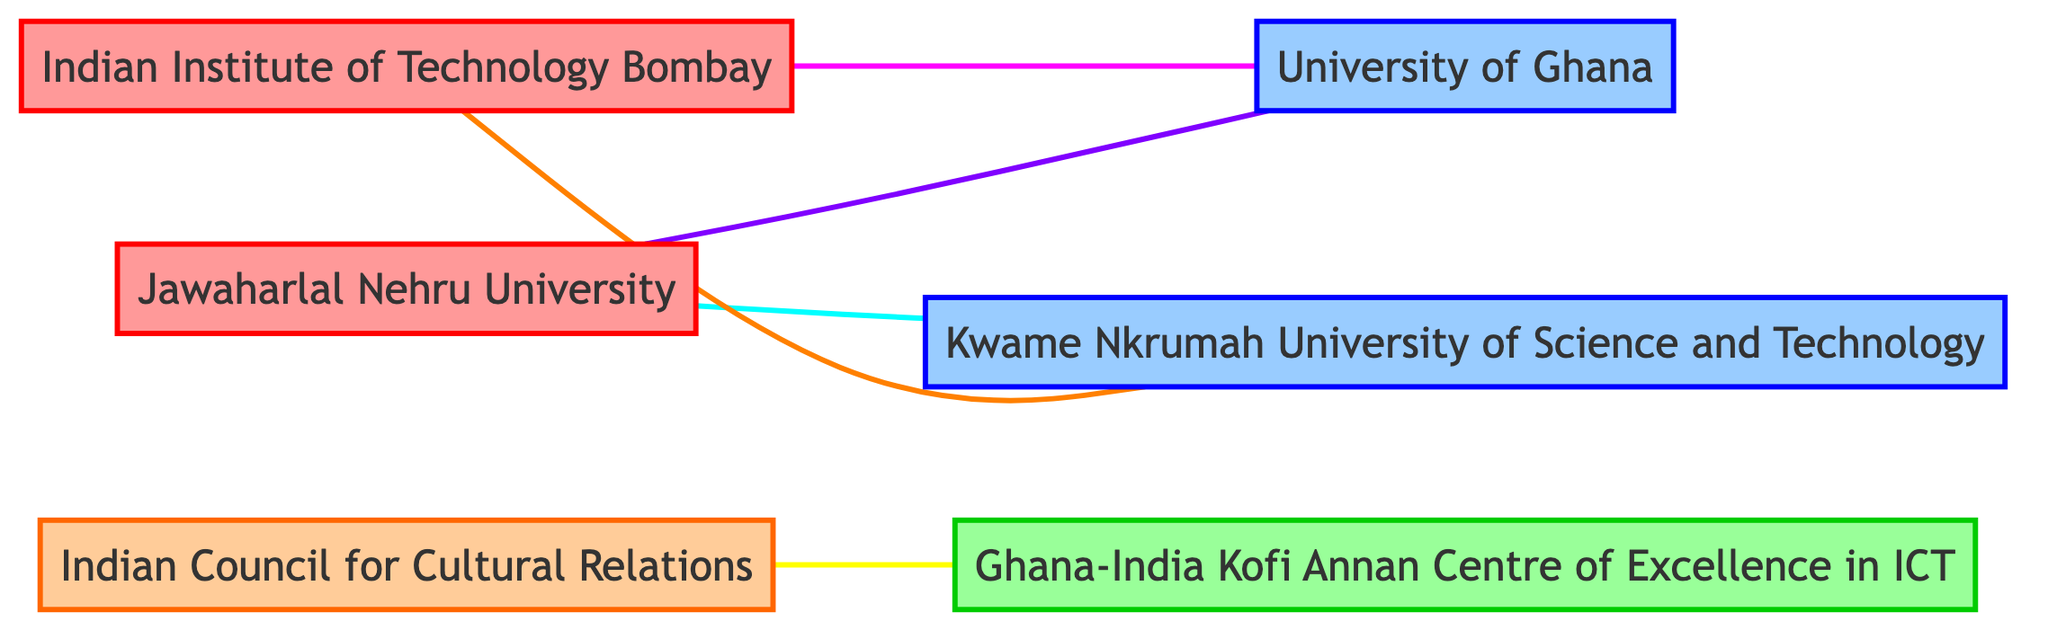What are the types of Indian educational institutions in the diagram? The diagram includes two nodes representing Indian educational institutions: Indian Institute of Technology Bombay and Jawaharlal Nehru University. Both are labeled as "Indian Educational Institution."
Answer: Indian Institute of Technology Bombay, Jawaharlal Nehru University How many edges represent collaboration between Indian and Ghanaian institutions? There are four edges connecting Indian institutions to Ghanaian institutions: one between Indian Institute of Technology Bombay and University of Ghana, another between Jawaharlal Nehru University and Kwame Nkrumah University of Science and Technology, and two more between Indian Institute of Technology Bombay and Kwame Nkrumah University of Science and Technology, and Jawaharlal Nehru University and University of Ghana. This totals four edges.
Answer: 4 What type of relationship exists between Indian Institute of Technology Bombay and University of Ghana? The edge connecting Indian Institute of Technology Bombay and University of Ghana is labeled as "Joint Research Projects," indicative of their collaboration.
Answer: Joint Research Projects Which Ghanaian organization collaborates with the Indian Council for Cultural Relations? The Ghanaian organization that collaborates with the Indian Council for Cultural Relations is the Ghana-India Kofi Annan Centre of Excellence in ICT, as indicated by the edge connecting the two nodes.
Answer: Ghana-India Kofi Annan Centre of Excellence in ICT How many nodes represent Ghanaian educational institutions? The diagram presents two nodes designated as Ghanaian educational institutions: University of Ghana and Kwame Nkrumah University of Science and Technology. Therefore, the count of Ghanaian educational institutions represented is two.
Answer: 2 What is the relationship type between Jawaharlal Nehru University and Kwame Nkrumah University of Science and Technology? The edge connecting Jawaharlal Nehru University and Kwame Nkrumah University of Science and Technology indicates a "Student Exchange Programs" relationship, representing the collaborative nature of their partnership.
Answer: Student Exchange Programs Which Indian institution has a connection to both Ghanaian institutions represented in the diagram? The Indian Institute of Technology Bombay is connected to both Ghanaian institutions: University of Ghana and Kwame Nkrumah University of Science and Technology, indicating its active engagement in multiple collaborations.
Answer: Indian Institute of Technology Bombay What type of collaboration exists between Jawaharlal Nehru University and University of Ghana? The collaboration between Jawaharlal Nehru University and University of Ghana is identified as "Dual Degree Programs," which entails a partnership for shared academic recognition.
Answer: Dual Degree Programs 